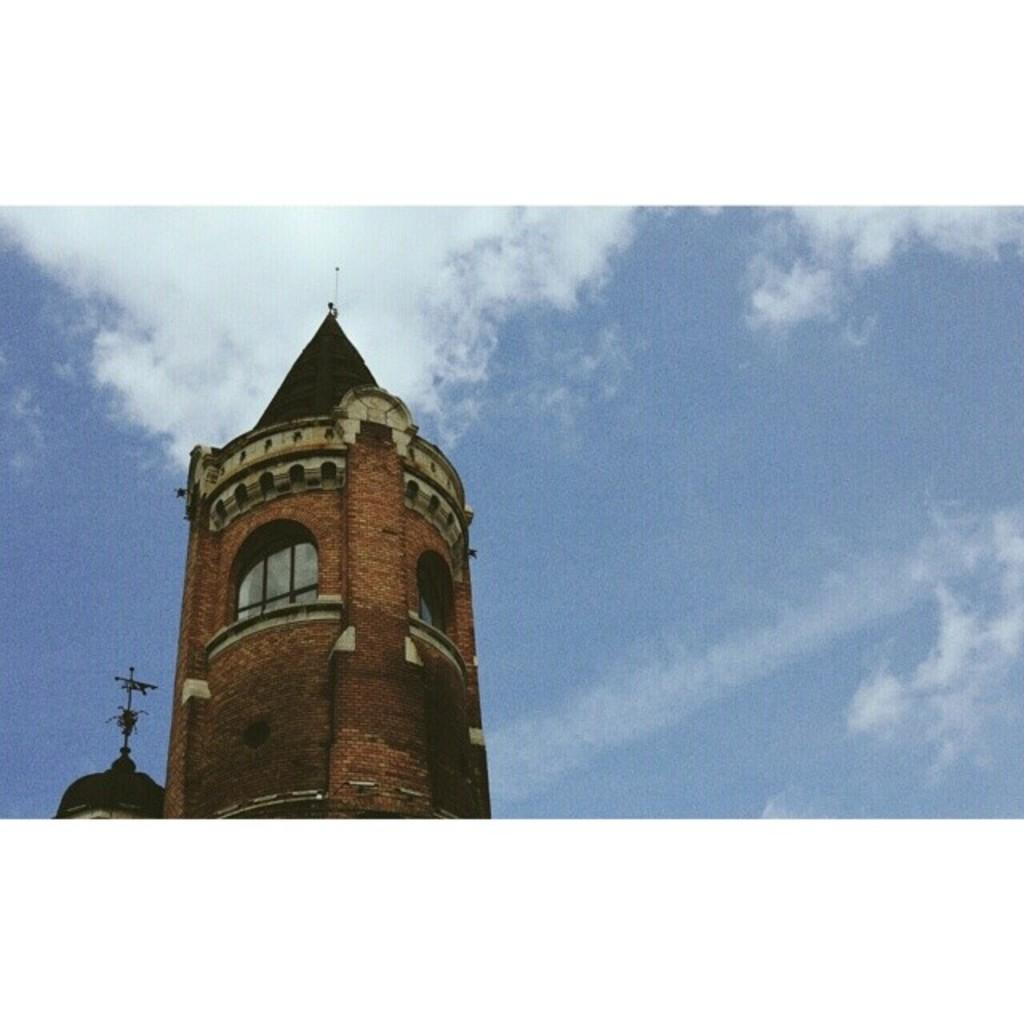What type of structures can be seen in the image? There are buildings in the image. What is the condition of the sky in the image? The sky is cloudy in the image. What material is the building made of? The building is made up of red bricks. How many times does the person in the image cough while wearing a mitten? There is no person in the image, nor is there a mitten present. 